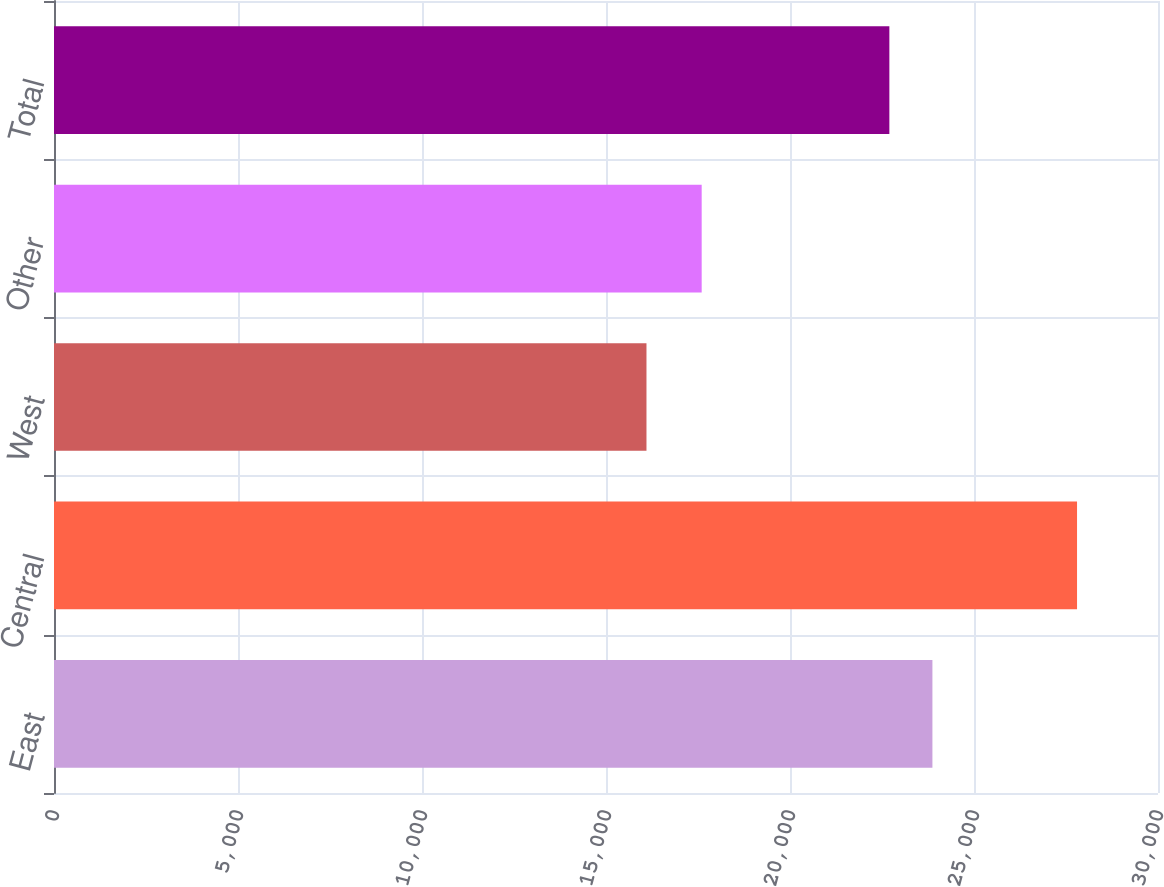<chart> <loc_0><loc_0><loc_500><loc_500><bar_chart><fcel>East<fcel>Central<fcel>West<fcel>Other<fcel>Total<nl><fcel>23870<fcel>27800<fcel>16100<fcel>17600<fcel>22700<nl></chart> 